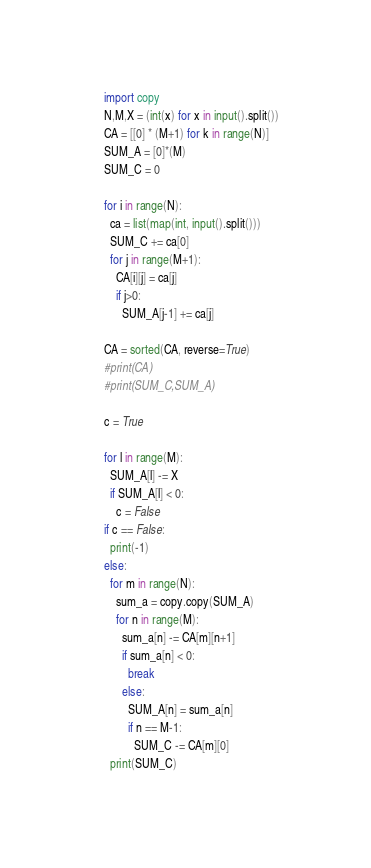Convert code to text. <code><loc_0><loc_0><loc_500><loc_500><_Python_>    import copy
    N,M,X = (int(x) for x in input().split())
    CA = [[0] * (M+1) for k in range(N)]
    SUM_A = [0]*(M)
    SUM_C = 0
    
    for i in range(N):
      ca = list(map(int, input().split()))
      SUM_C += ca[0]
      for j in range(M+1):
        CA[i][j] = ca[j]
        if j>0:
          SUM_A[j-1] += ca[j] 
    
    CA = sorted(CA, reverse=True)
    #print(CA)
    #print(SUM_C,SUM_A)

    c = True

    for l in range(M):
      SUM_A[l] -= X
      if SUM_A[l] < 0:
        c = False
    if c == False:
      print(-1)
    else:
      for m in range(N):
        sum_a = copy.copy(SUM_A)
        for n in range(M):
          sum_a[n] -= CA[m][n+1]
          if sum_a[n] < 0:
            break
          else:
            SUM_A[n] = sum_a[n]
            if n == M-1:
              SUM_C -= CA[m][0]
      print(SUM_C)</code> 